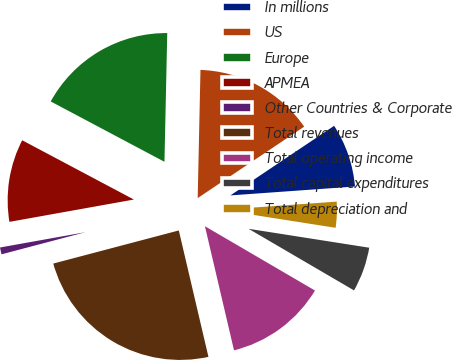<chart> <loc_0><loc_0><loc_500><loc_500><pie_chart><fcel>In millions<fcel>US<fcel>Europe<fcel>APMEA<fcel>Other Countries & Corporate<fcel>Total revenues<fcel>Total operating income<fcel>Total capital expenditures<fcel>Total depreciation and<nl><fcel>8.27%<fcel>15.25%<fcel>17.58%<fcel>10.59%<fcel>1.28%<fcel>24.56%<fcel>12.92%<fcel>5.94%<fcel>3.61%<nl></chart> 